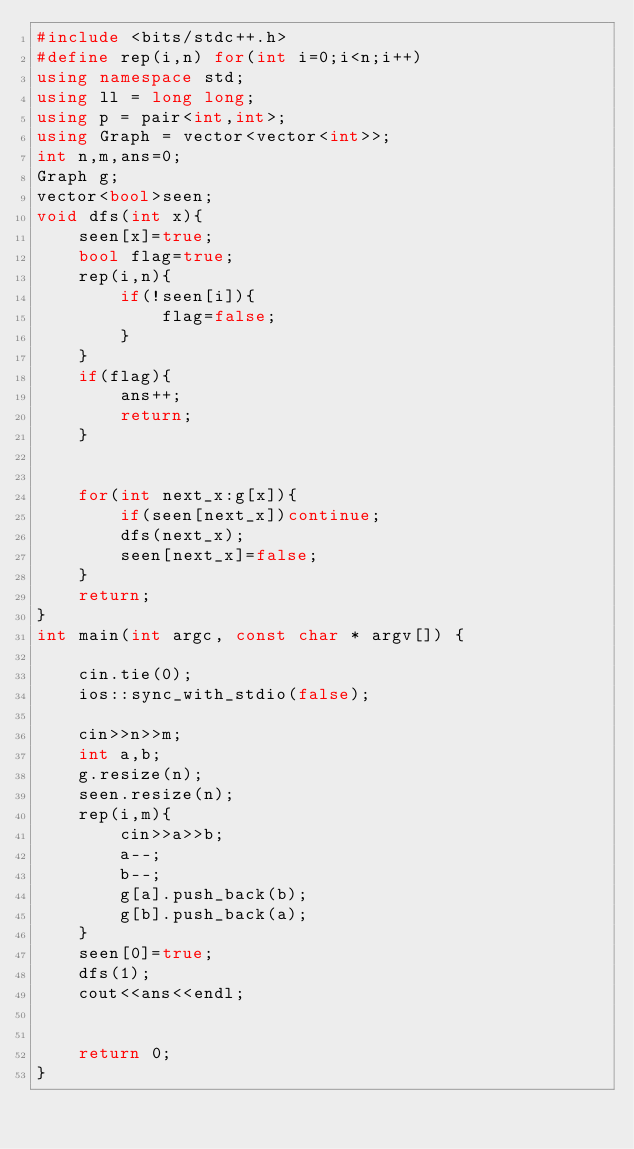Convert code to text. <code><loc_0><loc_0><loc_500><loc_500><_C++_>#include <bits/stdc++.h>
#define rep(i,n) for(int i=0;i<n;i++)
using namespace std;
using ll = long long;
using p = pair<int,int>;
using Graph = vector<vector<int>>;
int n,m,ans=0;
Graph g;
vector<bool>seen;
void dfs(int x){
    seen[x]=true;
    bool flag=true;
    rep(i,n){
        if(!seen[i]){
            flag=false;
        }
    }
    if(flag){
        ans++;
        return;
    }


    for(int next_x:g[x]){
        if(seen[next_x])continue;
        dfs(next_x);
        seen[next_x]=false;
    }
    return;
}
int main(int argc, const char * argv[]) {

    cin.tie(0);
    ios::sync_with_stdio(false);

    cin>>n>>m;
    int a,b;
    g.resize(n);
    seen.resize(n);
    rep(i,m){
        cin>>a>>b;
        a--;
        b--;
        g[a].push_back(b);
        g[b].push_back(a);
    }
    seen[0]=true;
    dfs(1);
    cout<<ans<<endl;


    return 0;
}

</code> 